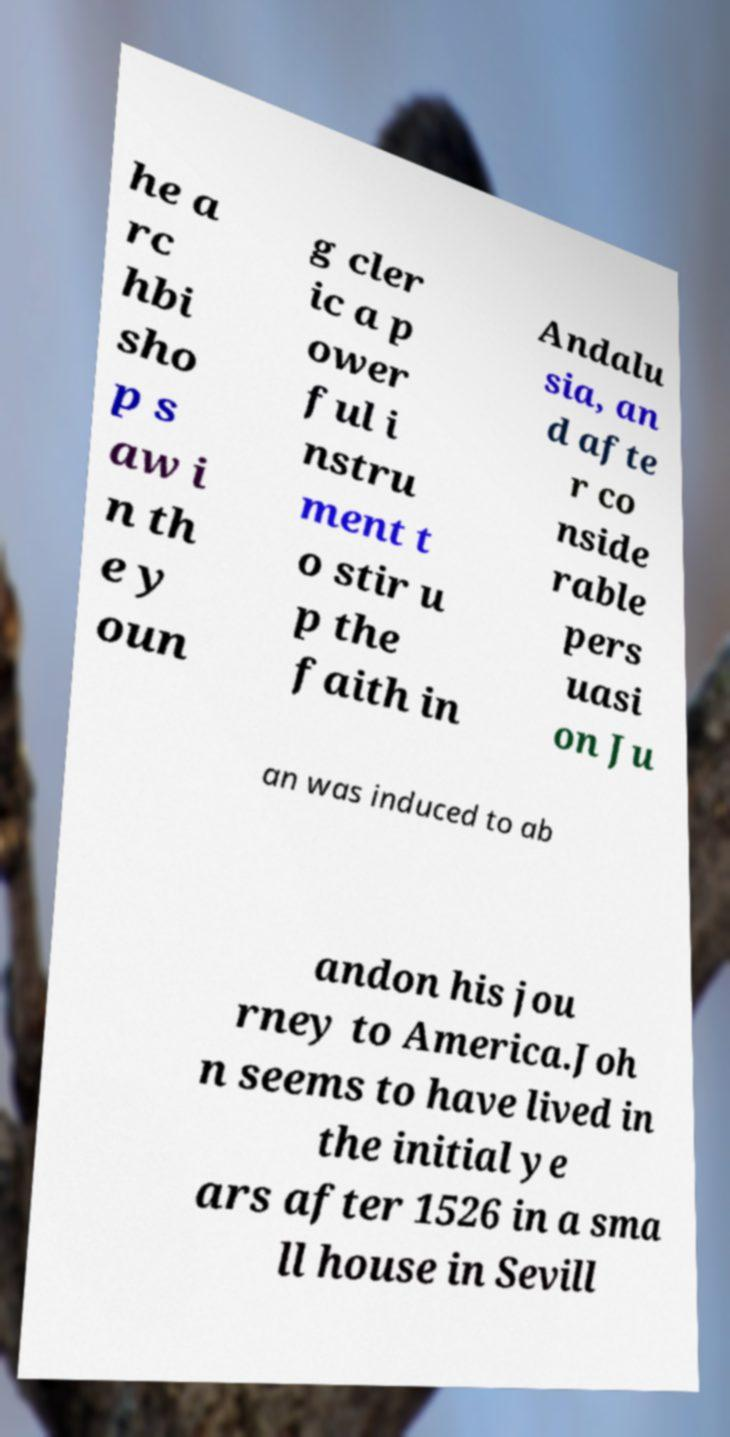For documentation purposes, I need the text within this image transcribed. Could you provide that? he a rc hbi sho p s aw i n th e y oun g cler ic a p ower ful i nstru ment t o stir u p the faith in Andalu sia, an d afte r co nside rable pers uasi on Ju an was induced to ab andon his jou rney to America.Joh n seems to have lived in the initial ye ars after 1526 in a sma ll house in Sevill 